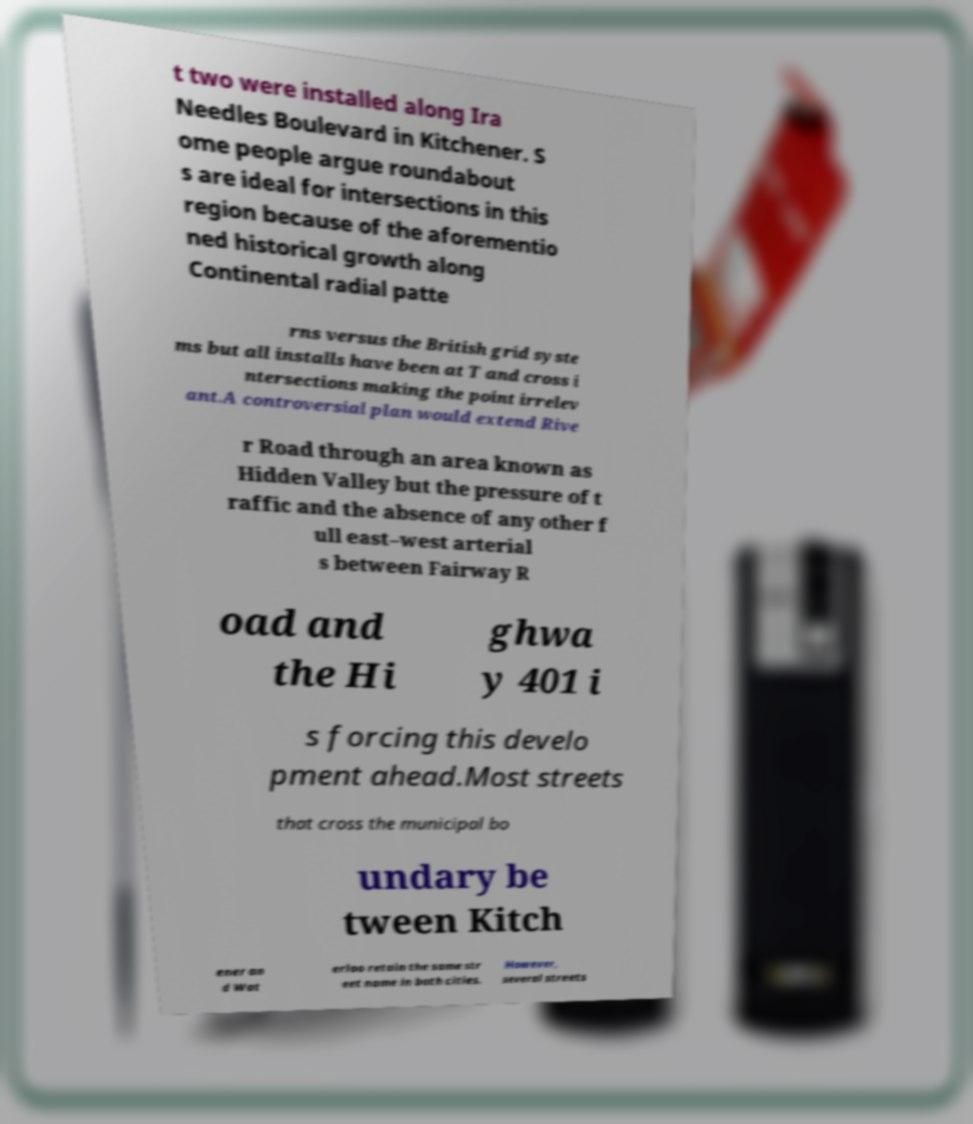There's text embedded in this image that I need extracted. Can you transcribe it verbatim? t two were installed along Ira Needles Boulevard in Kitchener. S ome people argue roundabout s are ideal for intersections in this region because of the aforementio ned historical growth along Continental radial patte rns versus the British grid syste ms but all installs have been at T and cross i ntersections making the point irrelev ant.A controversial plan would extend Rive r Road through an area known as Hidden Valley but the pressure of t raffic and the absence of any other f ull east–west arterial s between Fairway R oad and the Hi ghwa y 401 i s forcing this develo pment ahead.Most streets that cross the municipal bo undary be tween Kitch ener an d Wat erloo retain the same str eet name in both cities. However, several streets 